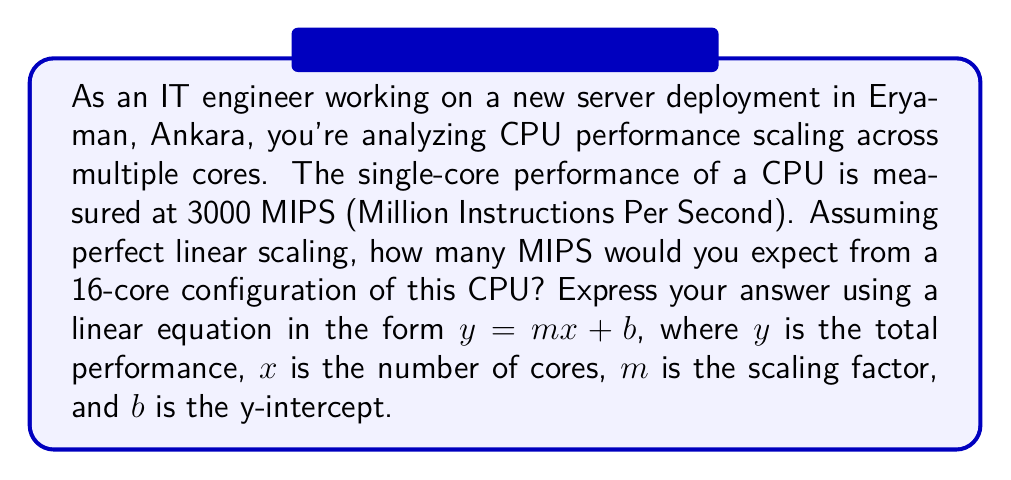Help me with this question. Let's approach this step-by-step:

1) We know that for a single core, the performance is 3000 MIPS. This gives us our scaling factor $m$.

2) In a linear equation $y = mx + b$, $m$ represents the slope or rate of change. In this case, it's the performance increase per core added.

3) So, $m = 3000$ MIPS/core

4) The y-intercept $b$ represents the performance when $x = 0$ (i.e., with no cores). Logically, this should be 0 MIPS.

5) Therefore, our linear equation is:

   $y = 3000x + 0$

   Which simplifies to:

   $y = 3000x$

6) To find the performance for 16 cores, we substitute $x = 16$:

   $y = 3000(16) = 48000$

Thus, with perfect linear scaling, a 16-core configuration would yield 48000 MIPS.
Answer: $y = 3000x$ 